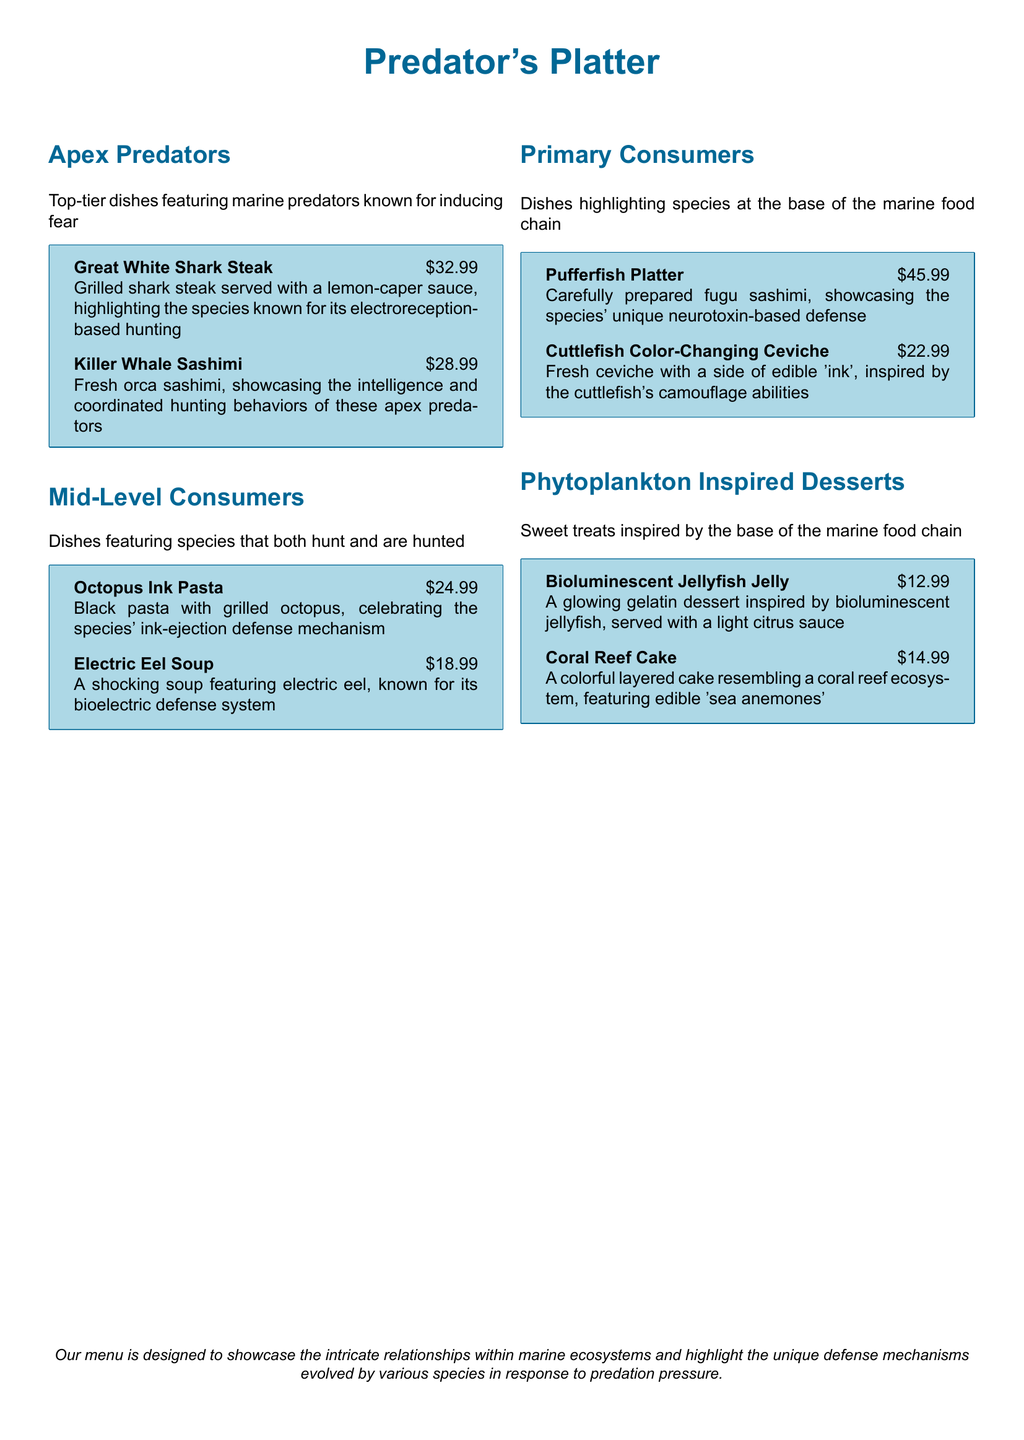what is the price of Great White Shark Steak? The price of Great White Shark Steak is stated as $32.99.
Answer: $32.99 how many desserts are listed on the menu? The menu lists two desserts under the Phytoplankton Inspired Desserts section: Bioluminescent Jellyfish Jelly and Coral Reef Cake.
Answer: 2 which dish features a neurotoxin-based defense? The dish that features a neurotoxin-based defense is the Pufferfish Platter, known for carefully prepared fugu sashimi.
Answer: Pufferfish Platter what is the main ingredient of the Electric Eel Soup? The main ingredient of the Electric Eel Soup is electric eel, highlighting its bioelectric defense system.
Answer: electric eel which section of the menu contains dishes made from apex predators? The dishes made from apex predators are found in the Apex Predators section of the menu.
Answer: Apex Predators what unique feature does the Cuttlefish Color-Changing Ceviche celebrate? The Cuttlefish Color-Changing Ceviche celebrates the cuttlefish's camouflage abilities.
Answer: camouflage abilities what type of cake resembles a coral reef ecosystem? The Coral Reef Cake is described as resembling a coral reef ecosystem with edible 'sea anemones.'
Answer: Coral Reef Cake how much does the Killer Whale Sashimi cost? The cost of the Killer Whale Sashimi is specified as $28.99.
Answer: $28.99 